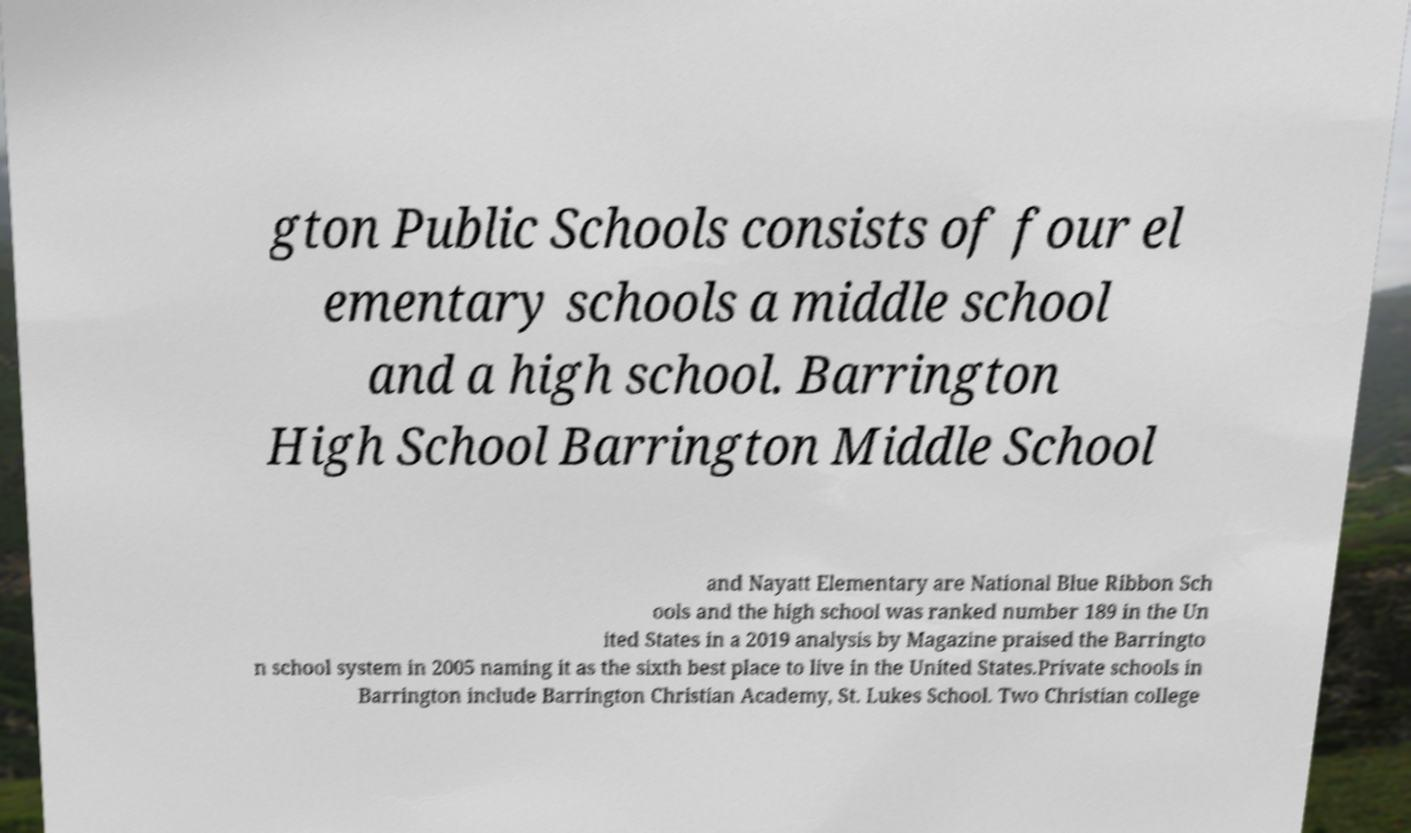Could you assist in decoding the text presented in this image and type it out clearly? gton Public Schools consists of four el ementary schools a middle school and a high school. Barrington High School Barrington Middle School and Nayatt Elementary are National Blue Ribbon Sch ools and the high school was ranked number 189 in the Un ited States in a 2019 analysis by Magazine praised the Barringto n school system in 2005 naming it as the sixth best place to live in the United States.Private schools in Barrington include Barrington Christian Academy, St. Lukes School. Two Christian college 